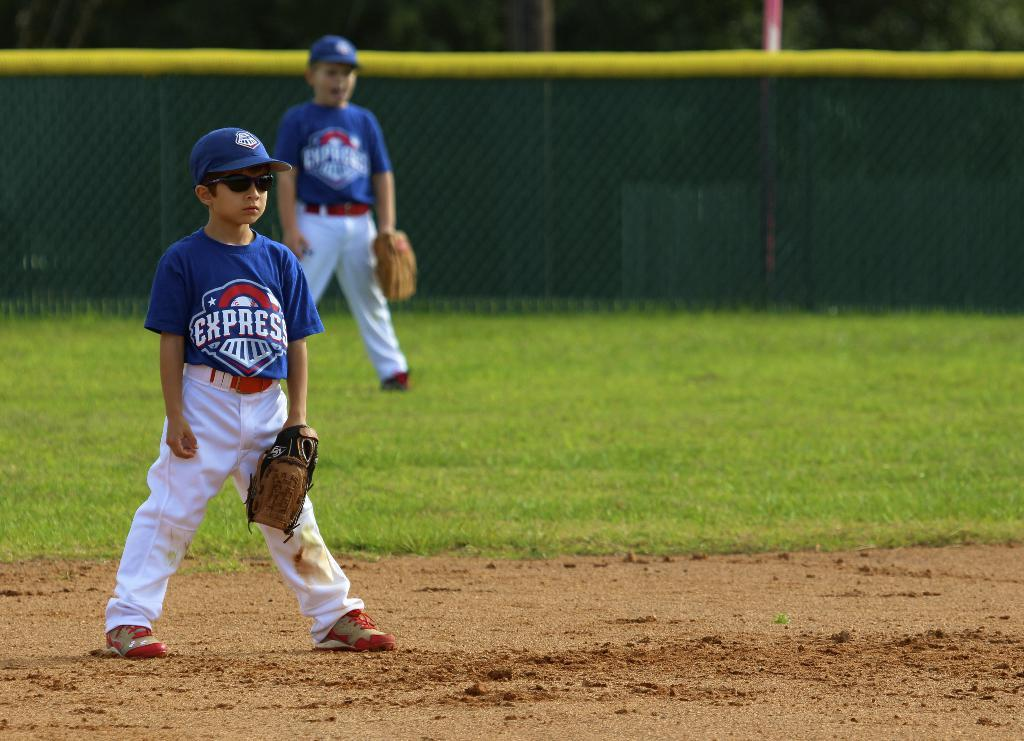<image>
Relay a brief, clear account of the picture shown. Baseball players for the Express team are on the field. 